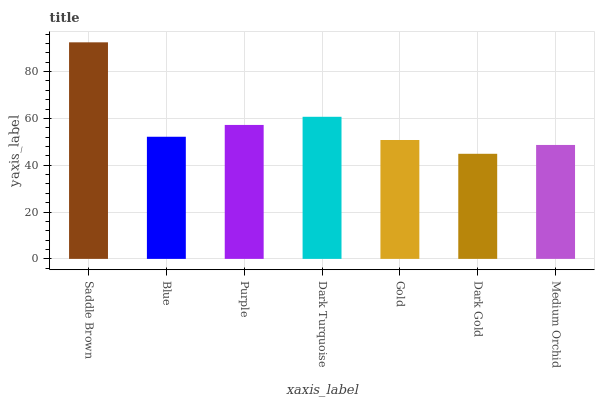Is Blue the minimum?
Answer yes or no. No. Is Blue the maximum?
Answer yes or no. No. Is Saddle Brown greater than Blue?
Answer yes or no. Yes. Is Blue less than Saddle Brown?
Answer yes or no. Yes. Is Blue greater than Saddle Brown?
Answer yes or no. No. Is Saddle Brown less than Blue?
Answer yes or no. No. Is Blue the high median?
Answer yes or no. Yes. Is Blue the low median?
Answer yes or no. Yes. Is Purple the high median?
Answer yes or no. No. Is Saddle Brown the low median?
Answer yes or no. No. 